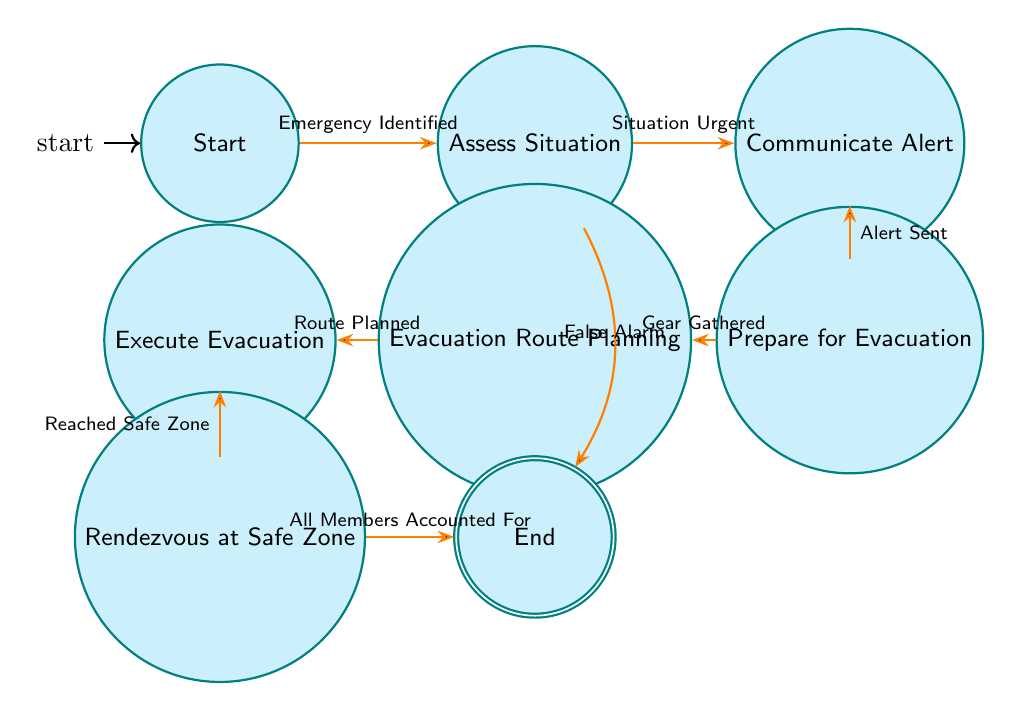What is the first state in the diagram? The first state in the diagram is labeled "Start." It is the initial state where the emergency protocol begins once a need for evacuation is recognized.
Answer: Start How many total states are present in the diagram? The diagram contains a total of eight states: Start, Assess Situation, Communicate Alert, Prepare for Evacuation, Evacuation Route Planning, Execute Evacuation, Rendezvous at Safe Zone, and End. Thus, the total count is eight.
Answer: 8 What transition occurs after "Prepare for Evacuation"? After the "Prepare for Evacuation" state, the transition to the next state is "Evacuation Route Planning," which happens after the trigger "Gear Gathered."
Answer: Evacuation Route Planning What triggers the transition from "Assess Situation" directly to "End"? The transition from "Assess Situation" directly to "End" is triggered by "False Alarm." This indicates that the situation does not require any further actions, and the protocol can conclude without evacuation.
Answer: False Alarm Which state requires the trigger "All Members Accounted For" to reach the "End"? The state that requires the trigger "All Members Accounted For" to transition to the "End" state is "Rendezvous at Safe Zone." This indicates that all members must be accounted for before concluding the evacuation process.
Answer: Rendezvous at Safe Zone How many transitions are defined in the diagram? The diagram includes a total of seven transitions that guide the flow from one state to another based on specific triggers.
Answer: 7 In which state do team members prepare necessary supplies for evacuation? Team members prepare necessary supplies for evacuation in the state labeled "Prepare for Evacuation." This state involves gathering essential gear and supplies crucial for a safe evacuation.
Answer: Prepare for Evacuation After which state does the team execute the evacuation plan? The team executes the evacuation plan after the state "Evacuation Route Planning." Once the route is determined, the process advances to executing the evacuation.
Answer: Execute Evacuation 